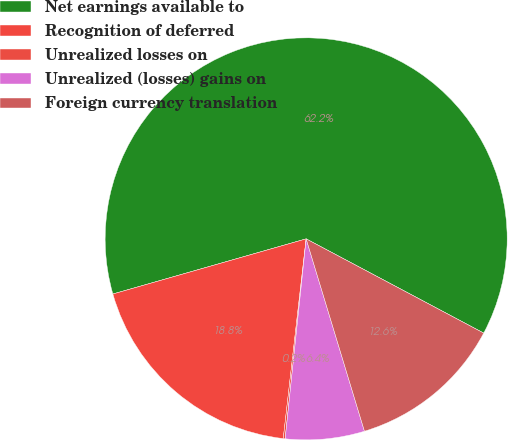Convert chart to OTSL. <chart><loc_0><loc_0><loc_500><loc_500><pie_chart><fcel>Net earnings available to<fcel>Recognition of deferred<fcel>Unrealized losses on<fcel>Unrealized (losses) gains on<fcel>Foreign currency translation<nl><fcel>62.19%<fcel>18.76%<fcel>0.15%<fcel>6.35%<fcel>12.55%<nl></chart> 